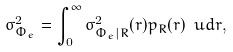Convert formula to latex. <formula><loc_0><loc_0><loc_500><loc_500>\sigma _ { \Phi _ { e } } ^ { 2 } = \int _ { 0 } ^ { \infty } \sigma _ { \Phi _ { e } | R } ^ { 2 } ( r ) p _ { R } ( r ) \ u d r ,</formula> 